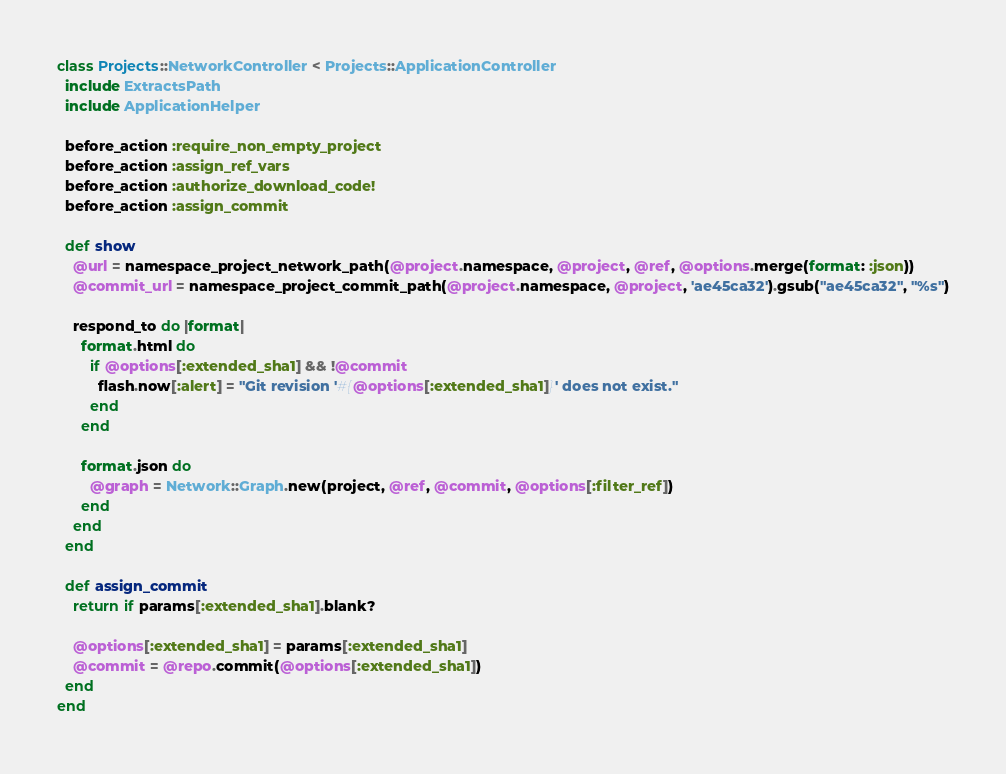Convert code to text. <code><loc_0><loc_0><loc_500><loc_500><_Ruby_>class Projects::NetworkController < Projects::ApplicationController
  include ExtractsPath
  include ApplicationHelper

  before_action :require_non_empty_project
  before_action :assign_ref_vars
  before_action :authorize_download_code!
  before_action :assign_commit

  def show
    @url = namespace_project_network_path(@project.namespace, @project, @ref, @options.merge(format: :json))
    @commit_url = namespace_project_commit_path(@project.namespace, @project, 'ae45ca32').gsub("ae45ca32", "%s")

    respond_to do |format|
      format.html do
        if @options[:extended_sha1] && !@commit
          flash.now[:alert] = "Git revision '#{@options[:extended_sha1]}' does not exist."
        end
      end

      format.json do
        @graph = Network::Graph.new(project, @ref, @commit, @options[:filter_ref])
      end
    end
  end

  def assign_commit
    return if params[:extended_sha1].blank?

    @options[:extended_sha1] = params[:extended_sha1]
    @commit = @repo.commit(@options[:extended_sha1])
  end
end
</code> 